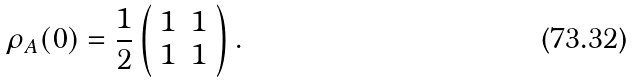<formula> <loc_0><loc_0><loc_500><loc_500>\rho _ { A } ( 0 ) = \frac { 1 } { 2 } \left ( \begin{array} { c c } 1 & 1 \\ 1 & 1 \end{array} \right ) .</formula> 